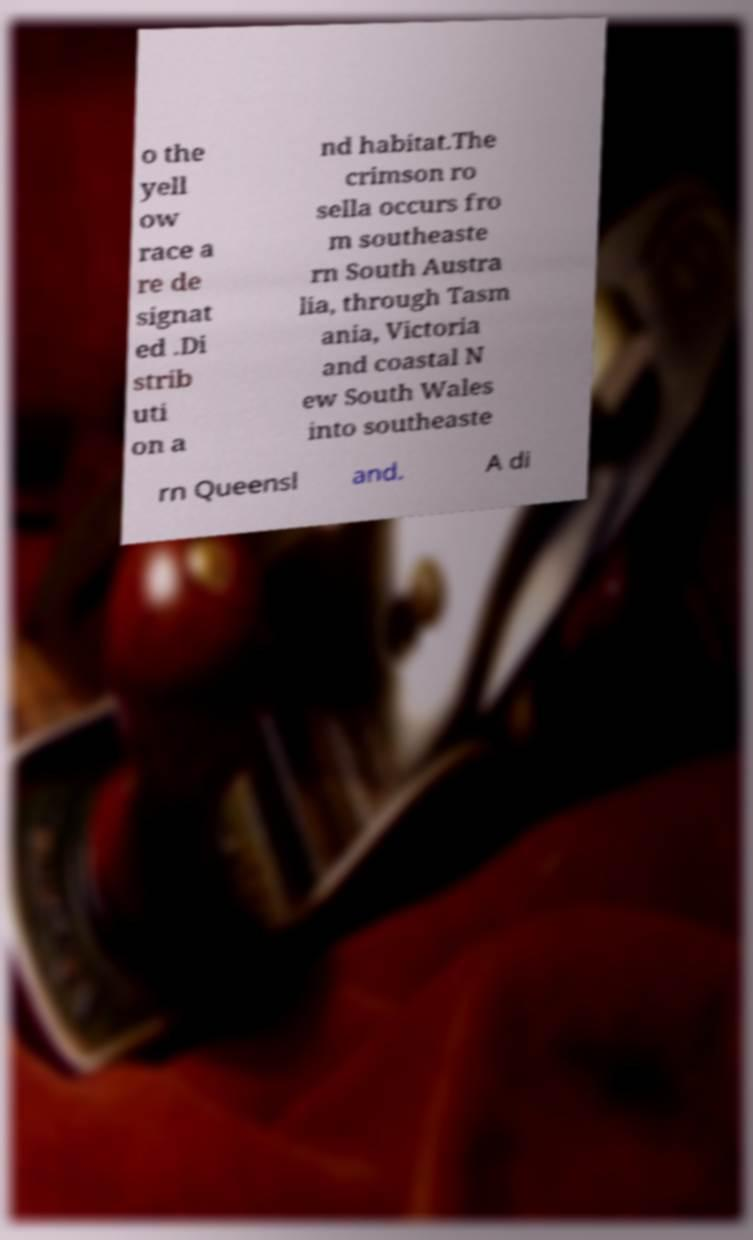I need the written content from this picture converted into text. Can you do that? o the yell ow race a re de signat ed .Di strib uti on a nd habitat.The crimson ro sella occurs fro m southeaste rn South Austra lia, through Tasm ania, Victoria and coastal N ew South Wales into southeaste rn Queensl and. A di 